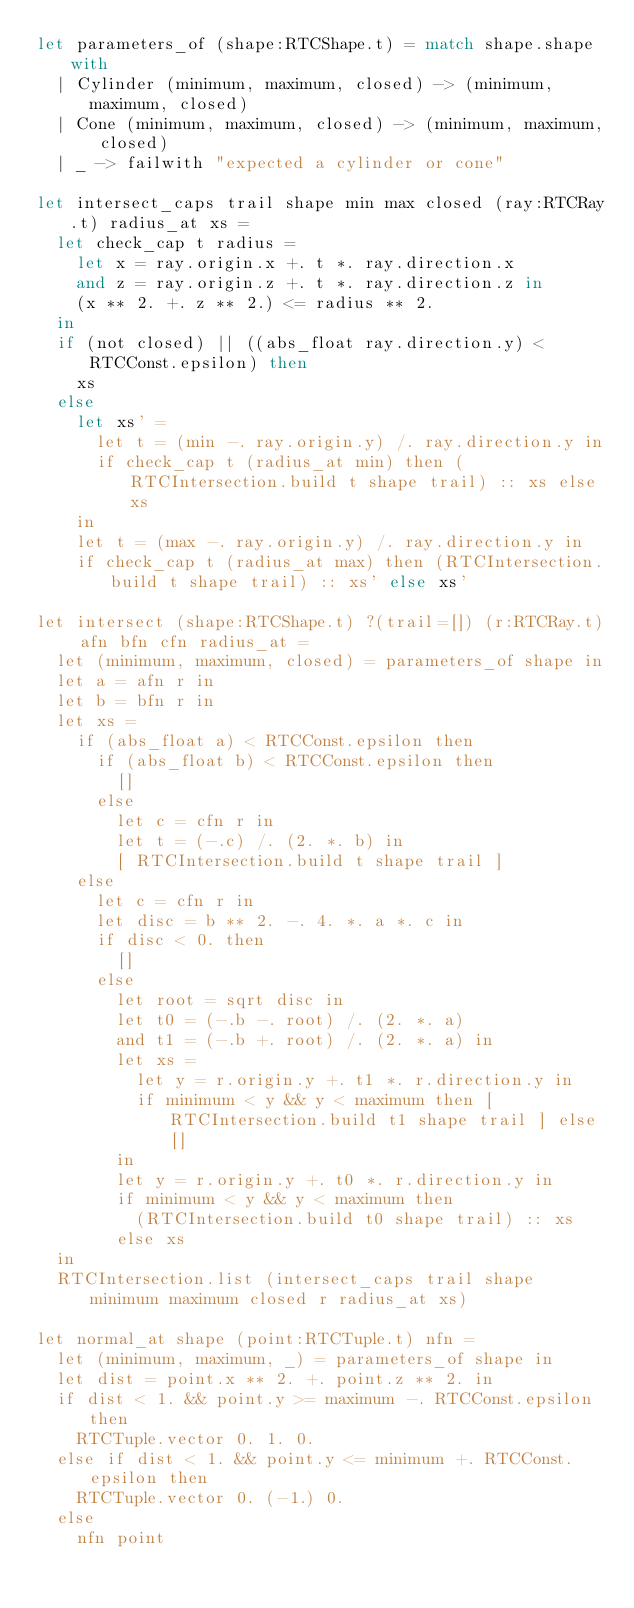Convert code to text. <code><loc_0><loc_0><loc_500><loc_500><_OCaml_>let parameters_of (shape:RTCShape.t) = match shape.shape with
  | Cylinder (minimum, maximum, closed) -> (minimum, maximum, closed)
  | Cone (minimum, maximum, closed) -> (minimum, maximum, closed)
  | _ -> failwith "expected a cylinder or cone"

let intersect_caps trail shape min max closed (ray:RTCRay.t) radius_at xs =
  let check_cap t radius =
    let x = ray.origin.x +. t *. ray.direction.x
    and z = ray.origin.z +. t *. ray.direction.z in
    (x ** 2. +. z ** 2.) <= radius ** 2.
  in
  if (not closed) || ((abs_float ray.direction.y) < RTCConst.epsilon) then
    xs
  else
    let xs' =
      let t = (min -. ray.origin.y) /. ray.direction.y in
      if check_cap t (radius_at min) then (RTCIntersection.build t shape trail) :: xs else xs
    in
    let t = (max -. ray.origin.y) /. ray.direction.y in
    if check_cap t (radius_at max) then (RTCIntersection.build t shape trail) :: xs' else xs'

let intersect (shape:RTCShape.t) ?(trail=[]) (r:RTCRay.t) afn bfn cfn radius_at =
  let (minimum, maximum, closed) = parameters_of shape in
  let a = afn r in
  let b = bfn r in
  let xs =
    if (abs_float a) < RTCConst.epsilon then
      if (abs_float b) < RTCConst.epsilon then
        []
      else
        let c = cfn r in
        let t = (-.c) /. (2. *. b) in
        [ RTCIntersection.build t shape trail ]
    else
      let c = cfn r in
      let disc = b ** 2. -. 4. *. a *. c in
      if disc < 0. then
        []
      else
        let root = sqrt disc in
        let t0 = (-.b -. root) /. (2. *. a)
        and t1 = (-.b +. root) /. (2. *. a) in
        let xs =
          let y = r.origin.y +. t1 *. r.direction.y in
          if minimum < y && y < maximum then [ RTCIntersection.build t1 shape trail ] else []
        in
        let y = r.origin.y +. t0 *. r.direction.y in
        if minimum < y && y < maximum then
          (RTCIntersection.build t0 shape trail) :: xs
        else xs
  in
  RTCIntersection.list (intersect_caps trail shape minimum maximum closed r radius_at xs)

let normal_at shape (point:RTCTuple.t) nfn =
  let (minimum, maximum, _) = parameters_of shape in
  let dist = point.x ** 2. +. point.z ** 2. in
  if dist < 1. && point.y >= maximum -. RTCConst.epsilon then
    RTCTuple.vector 0. 1. 0.
  else if dist < 1. && point.y <= minimum +. RTCConst.epsilon then
    RTCTuple.vector 0. (-1.) 0.
  else
    nfn point
</code> 